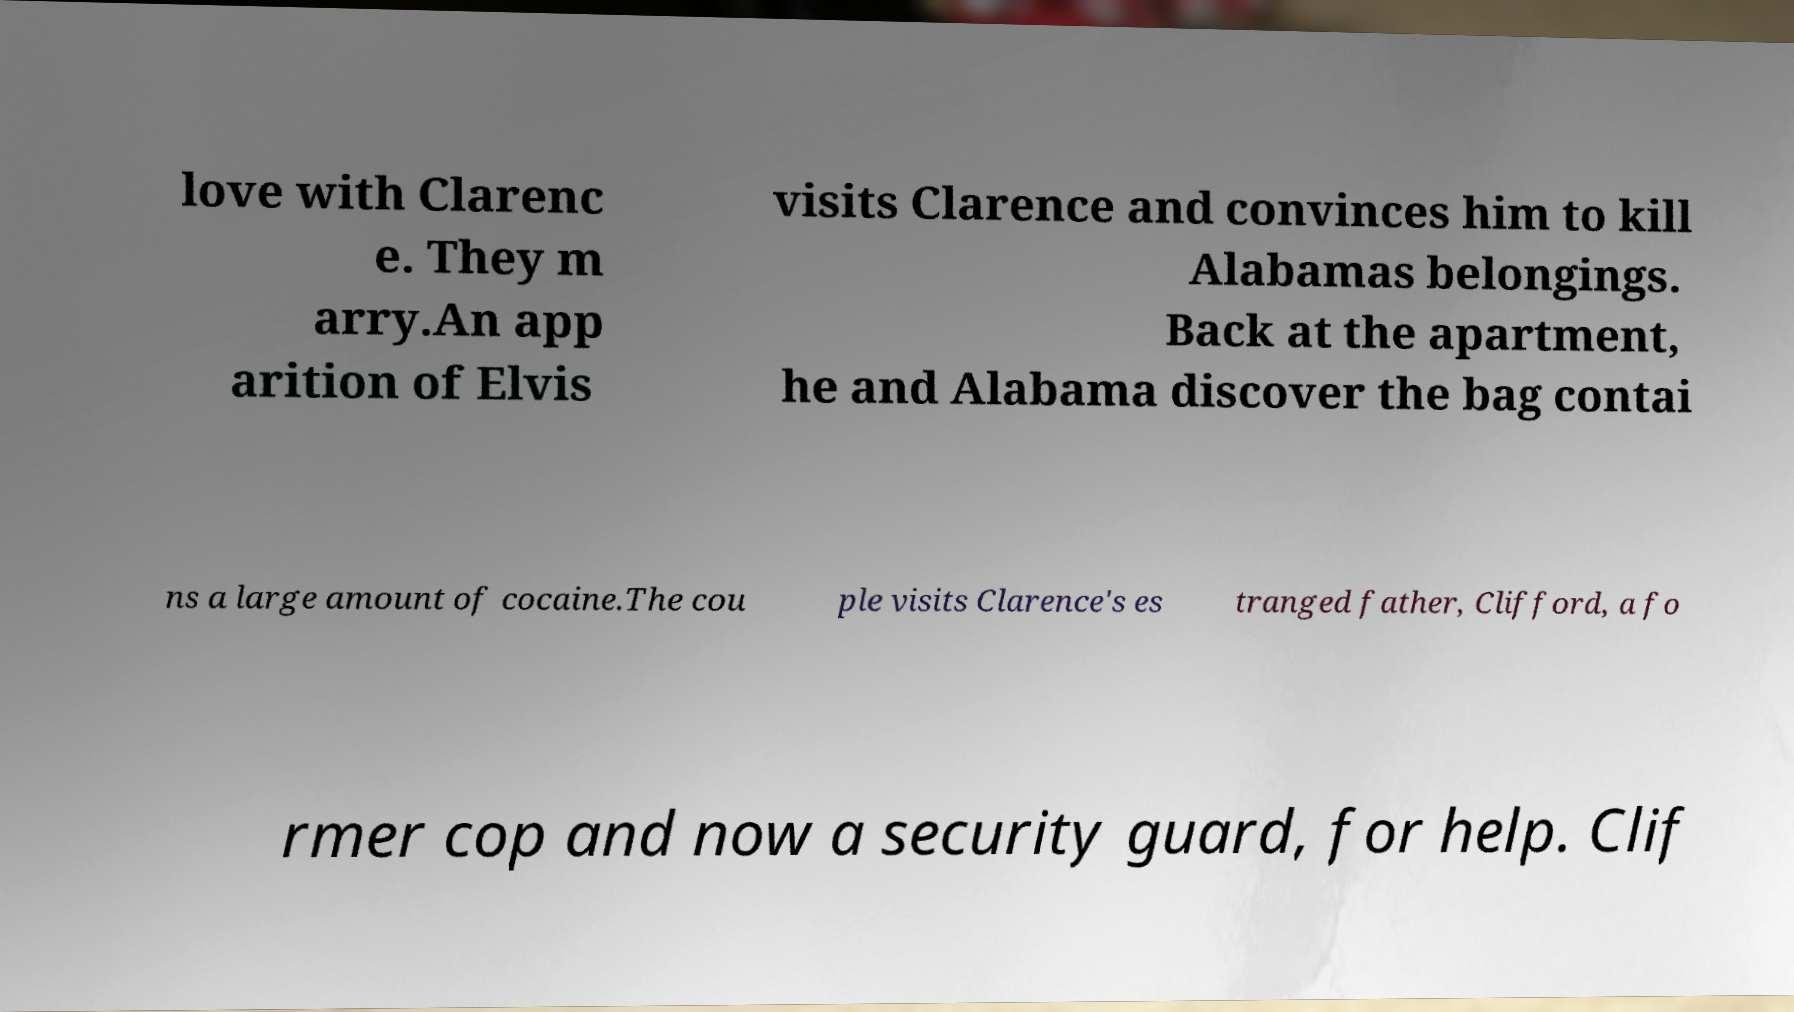What messages or text are displayed in this image? I need them in a readable, typed format. love with Clarenc e. They m arry.An app arition of Elvis visits Clarence and convinces him to kill Alabamas belongings. Back at the apartment, he and Alabama discover the bag contai ns a large amount of cocaine.The cou ple visits Clarence's es tranged father, Clifford, a fo rmer cop and now a security guard, for help. Clif 